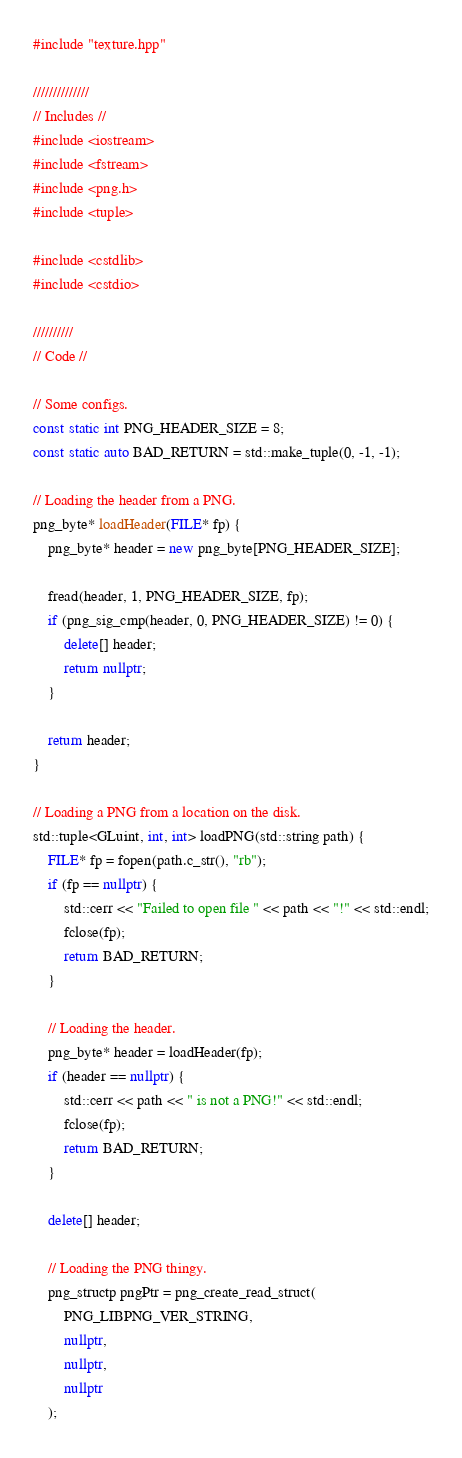Convert code to text. <code><loc_0><loc_0><loc_500><loc_500><_C++_>#include "texture.hpp"

//////////////
// Includes //
#include <iostream>
#include <fstream>
#include <png.h>
#include <tuple>

#include <cstdlib>
#include <cstdio>

//////////
// Code //

// Some configs.
const static int PNG_HEADER_SIZE = 8;
const static auto BAD_RETURN = std::make_tuple(0, -1, -1);

// Loading the header from a PNG.
png_byte* loadHeader(FILE* fp) {
    png_byte* header = new png_byte[PNG_HEADER_SIZE];

    fread(header, 1, PNG_HEADER_SIZE, fp);
    if (png_sig_cmp(header, 0, PNG_HEADER_SIZE) != 0) {
        delete[] header;
        return nullptr;
    }

    return header;
}

// Loading a PNG from a location on the disk.
std::tuple<GLuint, int, int> loadPNG(std::string path) {
    FILE* fp = fopen(path.c_str(), "rb");
    if (fp == nullptr) {
        std::cerr << "Failed to open file " << path << "!" << std::endl;
        fclose(fp);
        return BAD_RETURN;
    }

    // Loading the header.
    png_byte* header = loadHeader(fp);
    if (header == nullptr) {
        std::cerr << path << " is not a PNG!" << std::endl;
        fclose(fp);
        return BAD_RETURN;
    }

    delete[] header;

    // Loading the PNG thingy.
    png_structp pngPtr = png_create_read_struct(
        PNG_LIBPNG_VER_STRING,
        nullptr,
        nullptr,
        nullptr
    );
</code> 